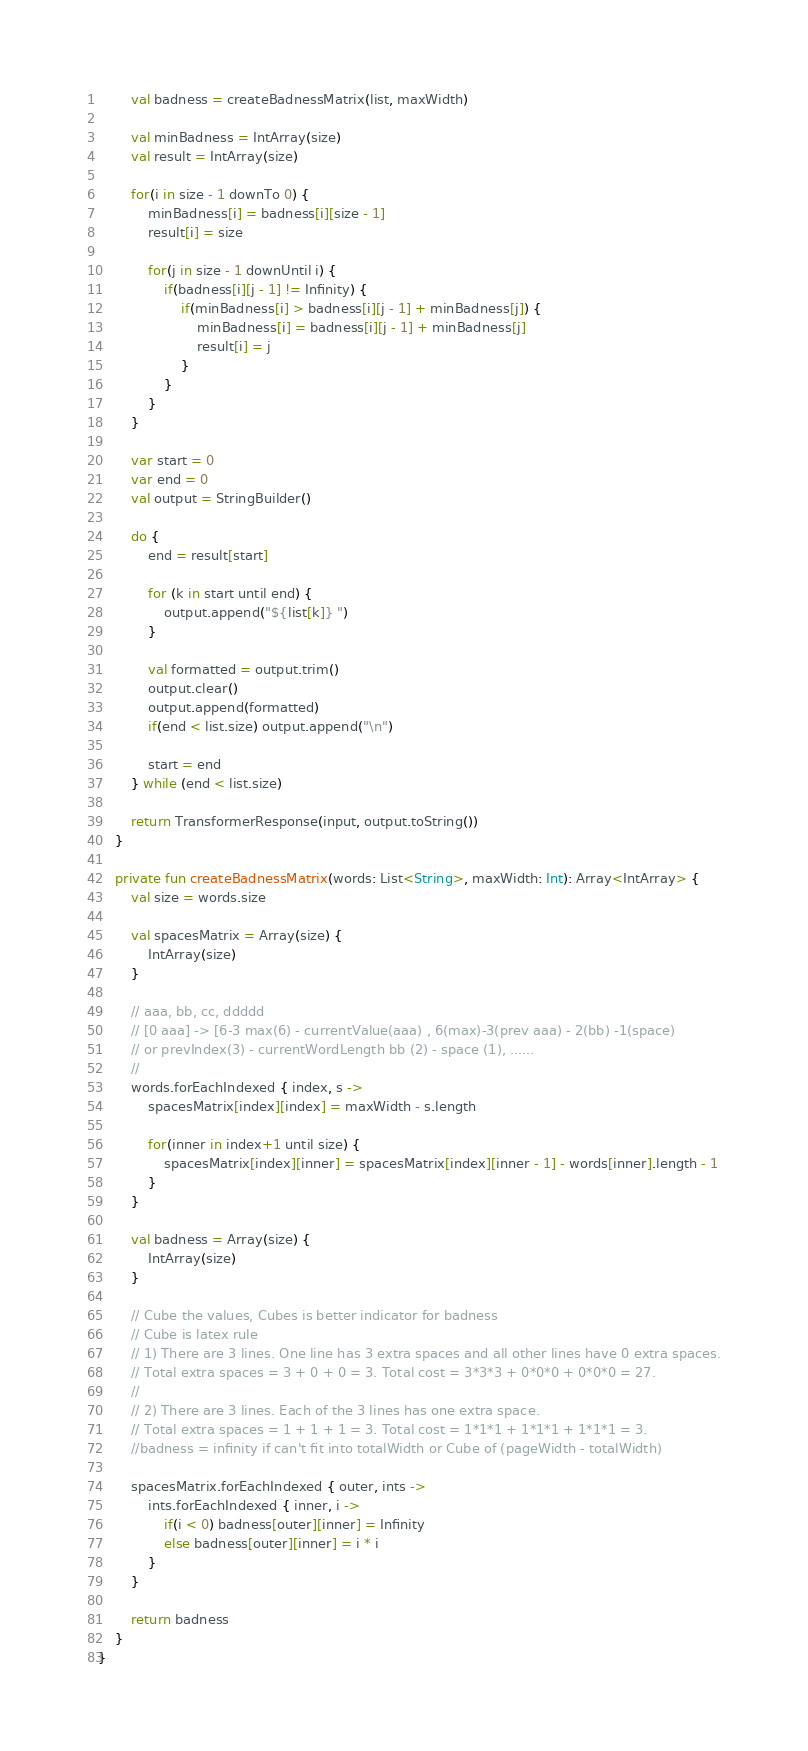Convert code to text. <code><loc_0><loc_0><loc_500><loc_500><_Kotlin_>        val badness = createBadnessMatrix(list, maxWidth)

        val minBadness = IntArray(size)
        val result = IntArray(size)

        for(i in size - 1 downTo 0) {
            minBadness[i] = badness[i][size - 1]
            result[i] = size

            for(j in size - 1 downUntil i) {
                if(badness[i][j - 1] != Infinity) {
                    if(minBadness[i] > badness[i][j - 1] + minBadness[j]) {
                        minBadness[i] = badness[i][j - 1] + minBadness[j]
                        result[i] = j
                    }
                }
            }
        }

        var start = 0
        var end = 0
        val output = StringBuilder()

        do {
            end = result[start]

            for (k in start until end) {
                output.append("${list[k]} ")
            }

            val formatted = output.trim()
            output.clear()
            output.append(formatted)
            if(end < list.size) output.append("\n")

            start = end
        } while (end < list.size)

        return TransformerResponse(input, output.toString())
    }

    private fun createBadnessMatrix(words: List<String>, maxWidth: Int): Array<IntArray> {
        val size = words.size

        val spacesMatrix = Array(size) {
            IntArray(size)
        }

        // aaa, bb, cc, ddddd
        // [0 aaa] -> [6-3 max(6) - currentValue(aaa) , 6(max)-3(prev aaa) - 2(bb) -1(space)
        // or prevIndex(3) - currentWordLength bb (2) - space (1), ......
        //
        words.forEachIndexed { index, s ->
            spacesMatrix[index][index] = maxWidth - s.length

            for(inner in index+1 until size) {
                spacesMatrix[index][inner] = spacesMatrix[index][inner - 1] - words[inner].length - 1
            }
        }

        val badness = Array(size) {
            IntArray(size)
        }

        // Cube the values, Cubes is better indicator for badness
        // Cube is latex rule
        // 1) There are 3 lines. One line has 3 extra spaces and all other lines have 0 extra spaces.
        // Total extra spaces = 3 + 0 + 0 = 3. Total cost = 3*3*3 + 0*0*0 + 0*0*0 = 27.
        //
        // 2) There are 3 lines. Each of the 3 lines has one extra space.
        // Total extra spaces = 1 + 1 + 1 = 3. Total cost = 1*1*1 + 1*1*1 + 1*1*1 = 3.
        //badness = infinity if can't fit into totalWidth or Cube of (pageWidth - totalWidth)

        spacesMatrix.forEachIndexed { outer, ints ->
            ints.forEachIndexed { inner, i ->
                if(i < 0) badness[outer][inner] = Infinity
                else badness[outer][inner] = i * i
            }
        }

        return badness
    }
}</code> 